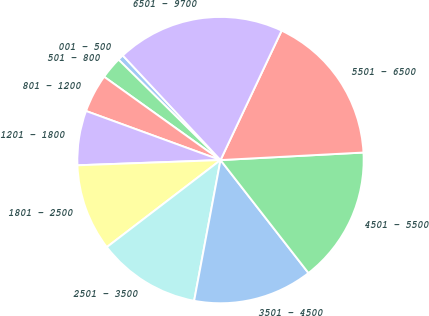Convert chart. <chart><loc_0><loc_0><loc_500><loc_500><pie_chart><fcel>001 - 500<fcel>501 - 800<fcel>801 - 1200<fcel>1201 - 1800<fcel>1801 - 2500<fcel>2501 - 3500<fcel>3501 - 4500<fcel>4501 - 5500<fcel>5501 - 6500<fcel>6501 - 9700<nl><fcel>0.66%<fcel>2.49%<fcel>4.32%<fcel>6.15%<fcel>9.82%<fcel>11.65%<fcel>13.48%<fcel>15.31%<fcel>17.14%<fcel>18.98%<nl></chart> 